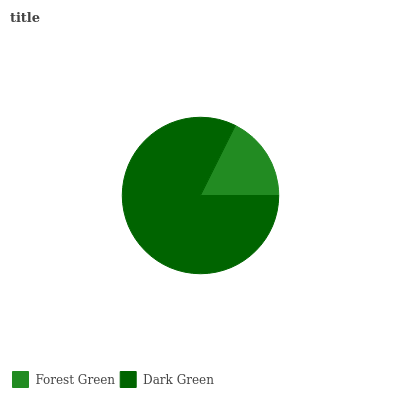Is Forest Green the minimum?
Answer yes or no. Yes. Is Dark Green the maximum?
Answer yes or no. Yes. Is Dark Green the minimum?
Answer yes or no. No. Is Dark Green greater than Forest Green?
Answer yes or no. Yes. Is Forest Green less than Dark Green?
Answer yes or no. Yes. Is Forest Green greater than Dark Green?
Answer yes or no. No. Is Dark Green less than Forest Green?
Answer yes or no. No. Is Dark Green the high median?
Answer yes or no. Yes. Is Forest Green the low median?
Answer yes or no. Yes. Is Forest Green the high median?
Answer yes or no. No. Is Dark Green the low median?
Answer yes or no. No. 